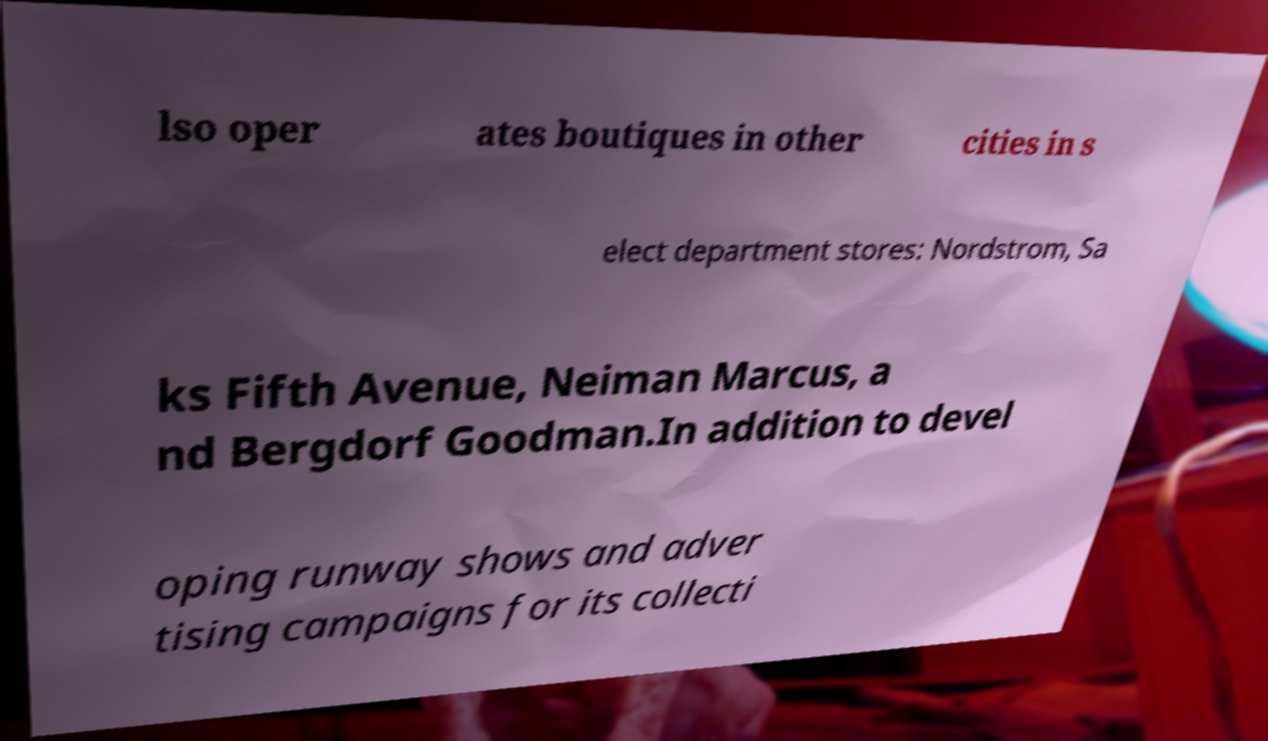For documentation purposes, I need the text within this image transcribed. Could you provide that? lso oper ates boutiques in other cities in s elect department stores: Nordstrom, Sa ks Fifth Avenue, Neiman Marcus, a nd Bergdorf Goodman.In addition to devel oping runway shows and adver tising campaigns for its collecti 